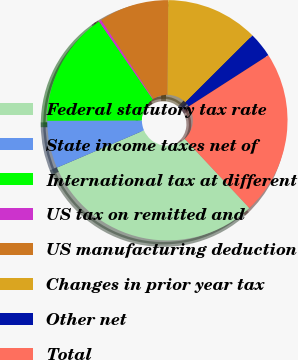Convert chart. <chart><loc_0><loc_0><loc_500><loc_500><pie_chart><fcel>Federal statutory tax rate<fcel>State income taxes net of<fcel>International tax at different<fcel>US tax on remitted and<fcel>US manufacturing deduction<fcel>Changes in prior year tax<fcel>Other net<fcel>Total<nl><fcel>30.51%<fcel>6.38%<fcel>15.43%<fcel>0.35%<fcel>9.4%<fcel>12.41%<fcel>3.37%<fcel>22.14%<nl></chart> 